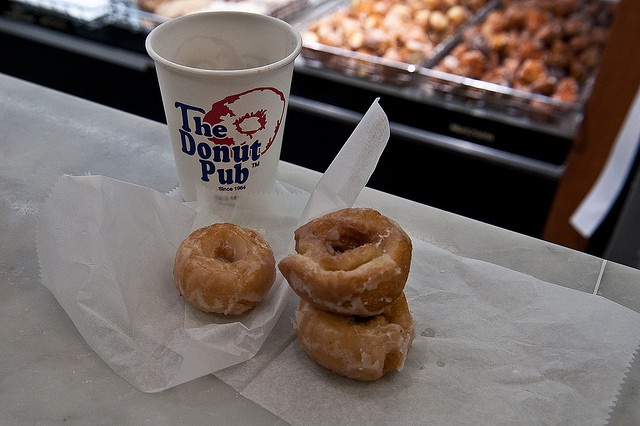Describe the objects in this image and their specific colors. I can see cup in black and gray tones, donut in black, maroon, gray, and brown tones, donut in black, maroon, gray, and brown tones, donut in black, maroon, and gray tones, and donut in black, gray, brown, darkgray, and maroon tones in this image. 